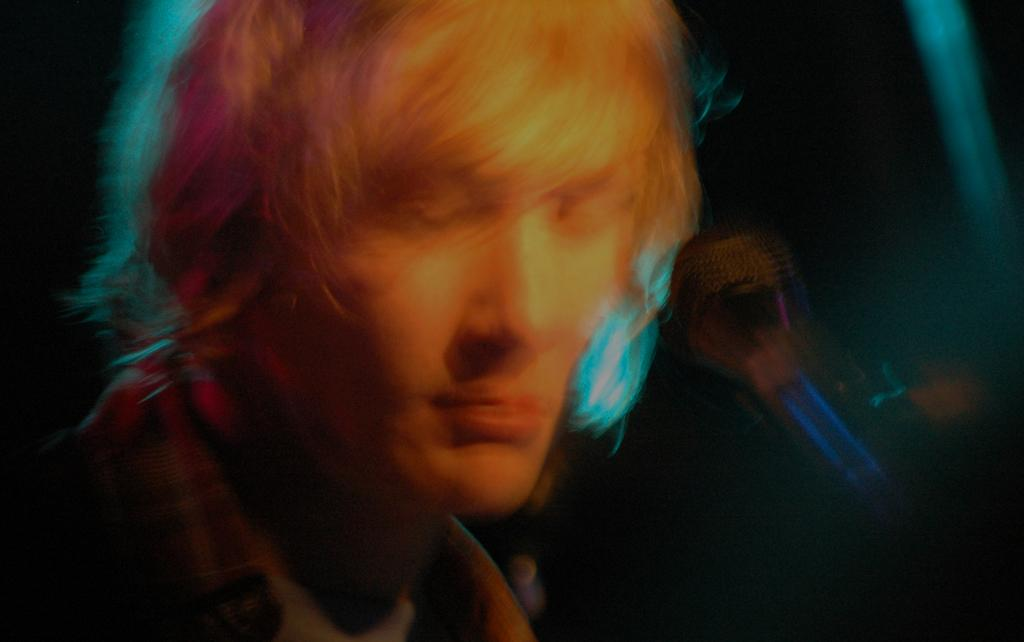What is the overall quality of the image? The image is blurry. Can you describe the person in the image? There is a man in the image. What is the man holding in the image? The man is holding a mic. What is unique about the man's hair? The man's hair has different colors. Can you see the mark on the moon in the image? There is no mark on the moon visible in the image, as the image is focused on a man holding a mic. 